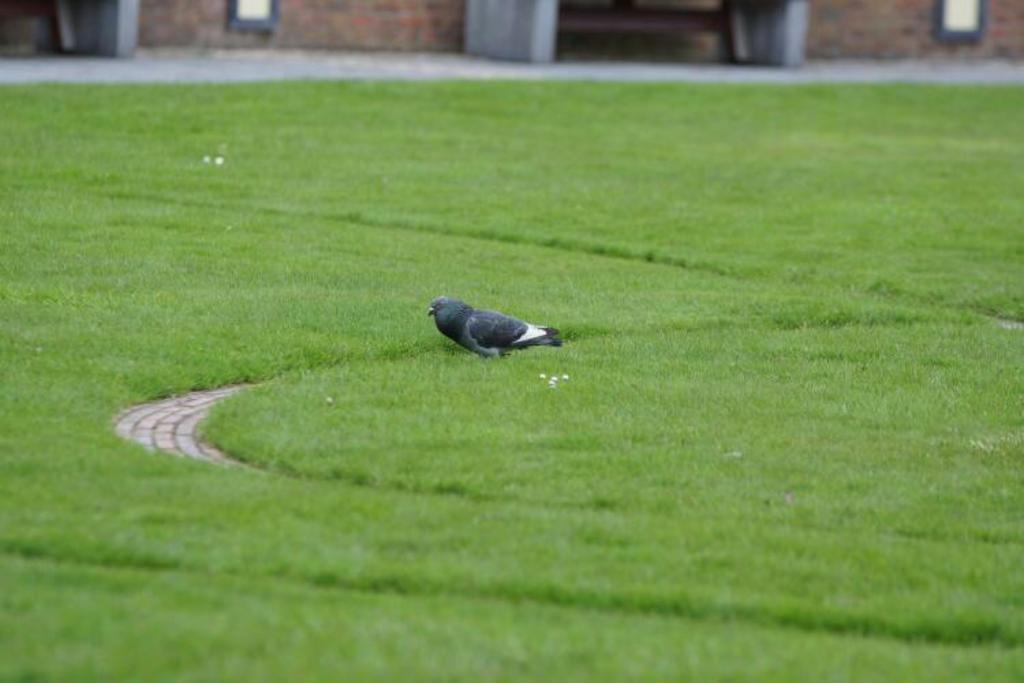Please provide a concise description of this image. This image is taken outdoors. At the bottom of the image there is a ground with grass on it. In the middle of the image there is a bird on the ground. In the background there is a wall and there is a road. 